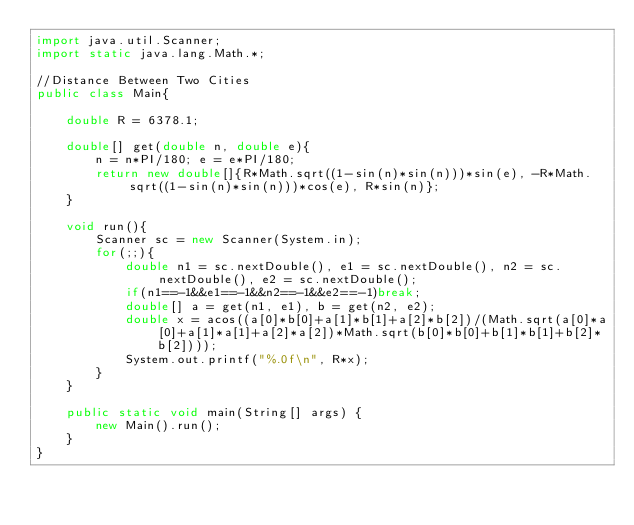<code> <loc_0><loc_0><loc_500><loc_500><_Java_>import java.util.Scanner;
import static java.lang.Math.*;

//Distance Between Two Cities
public class Main{

	double R = 6378.1;
	
	double[] get(double n, double e){
		n = n*PI/180; e = e*PI/180;
		return new double[]{R*Math.sqrt((1-sin(n)*sin(n)))*sin(e), -R*Math.sqrt((1-sin(n)*sin(n)))*cos(e), R*sin(n)};
	}

	void run(){
		Scanner sc = new Scanner(System.in);
		for(;;){
			double n1 = sc.nextDouble(), e1 = sc.nextDouble(), n2 = sc.nextDouble(), e2 = sc.nextDouble();
			if(n1==-1&&e1==-1&&n2==-1&&e2==-1)break;
			double[] a = get(n1, e1), b = get(n2, e2);
			double x = acos((a[0]*b[0]+a[1]*b[1]+a[2]*b[2])/(Math.sqrt(a[0]*a[0]+a[1]*a[1]+a[2]*a[2])*Math.sqrt(b[0]*b[0]+b[1]*b[1]+b[2]*b[2])));
			System.out.printf("%.0f\n", R*x);
		}
	}
	
	public static void main(String[] args) {
		new Main().run();
	}
}</code> 